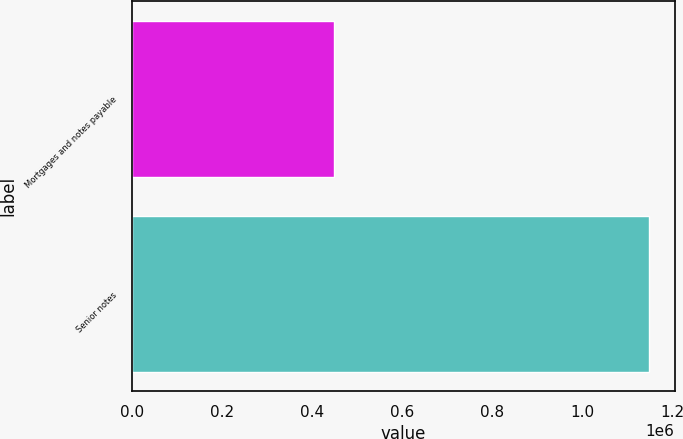Convert chart to OTSL. <chart><loc_0><loc_0><loc_500><loc_500><bar_chart><fcel>Mortgages and notes payable<fcel>Senior notes<nl><fcel>449130<fcel>1.14677e+06<nl></chart> 